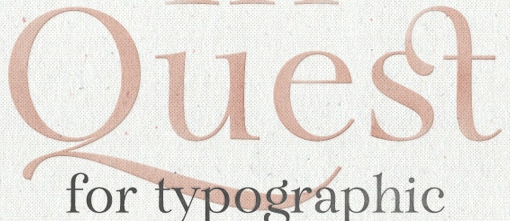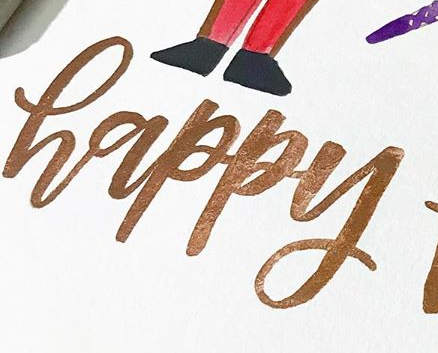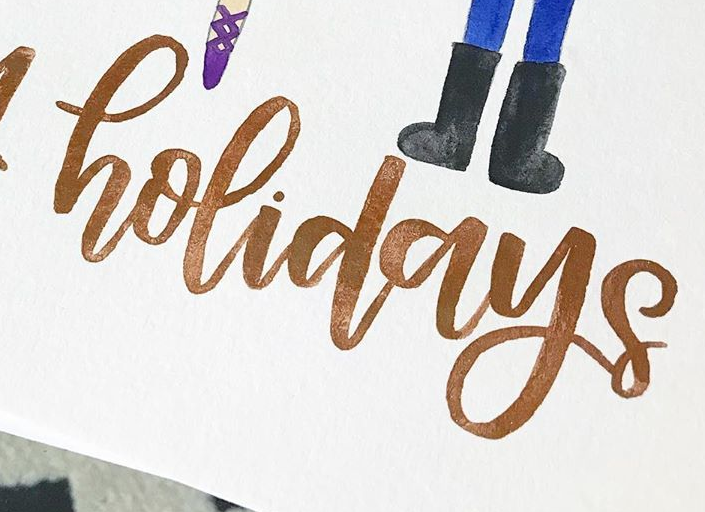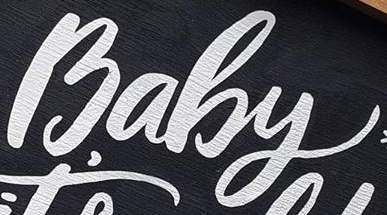What words can you see in these images in sequence, separated by a semicolon? Quest; happy; holidays; Baby 